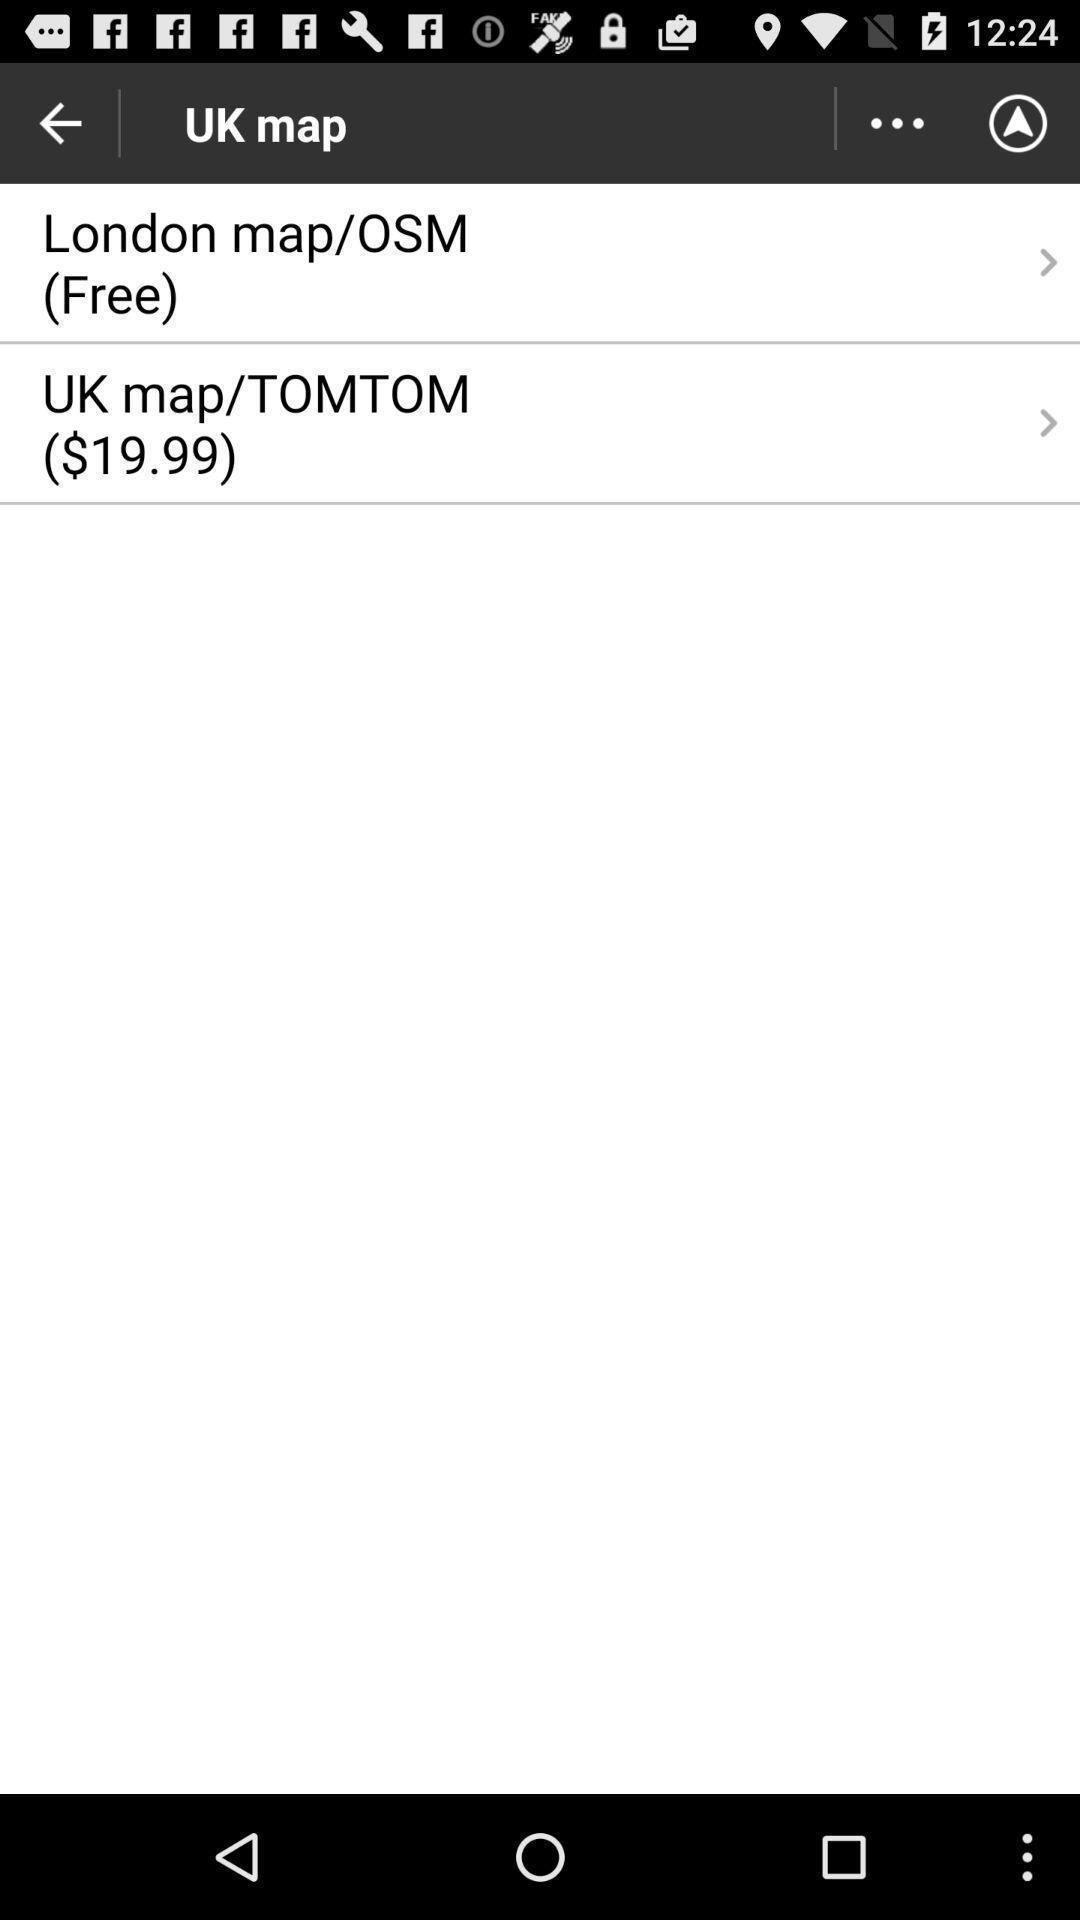Explain what's happening in this screen capture. Screen shows multiple options in a navigation application. 